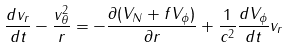<formula> <loc_0><loc_0><loc_500><loc_500>\frac { d v _ { r } } { d t } - \frac { v _ { \theta } ^ { 2 } } { r } = - \frac { \partial ( V _ { N } + f V _ { \phi } ) } { \partial r } + \frac { 1 } { c ^ { 2 } } \frac { d V _ { \phi } } { d t } v _ { r }</formula> 